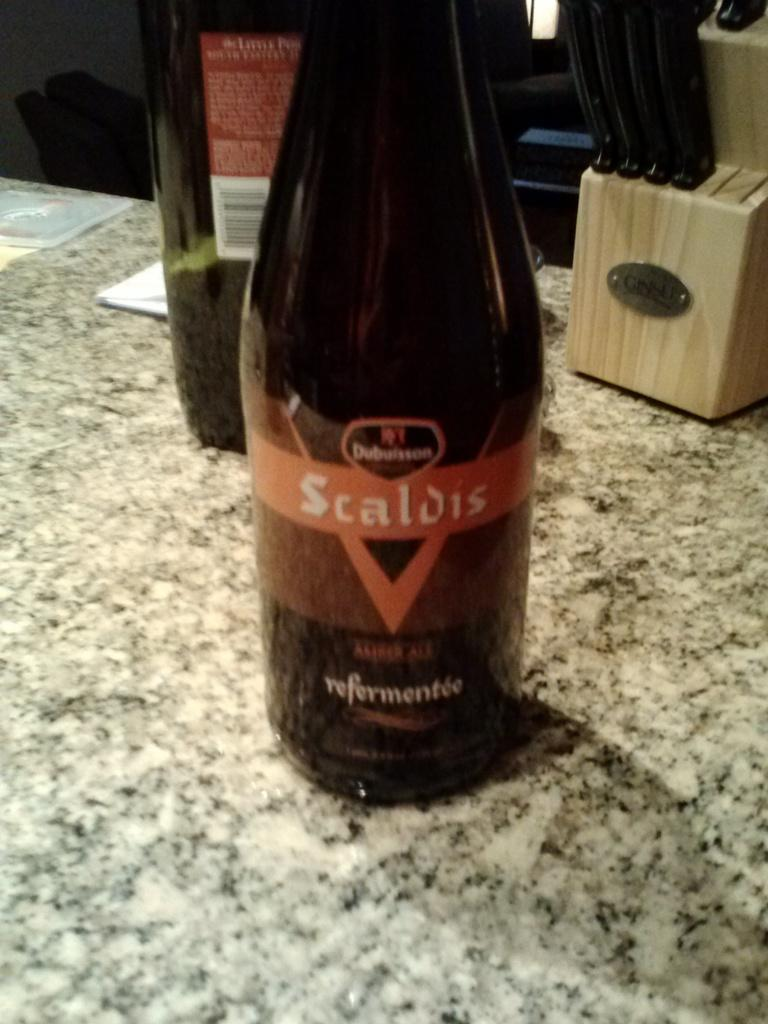<image>
Offer a succinct explanation of the picture presented. A bottle of Scaldis wine sits on a stone kitchen counter. 